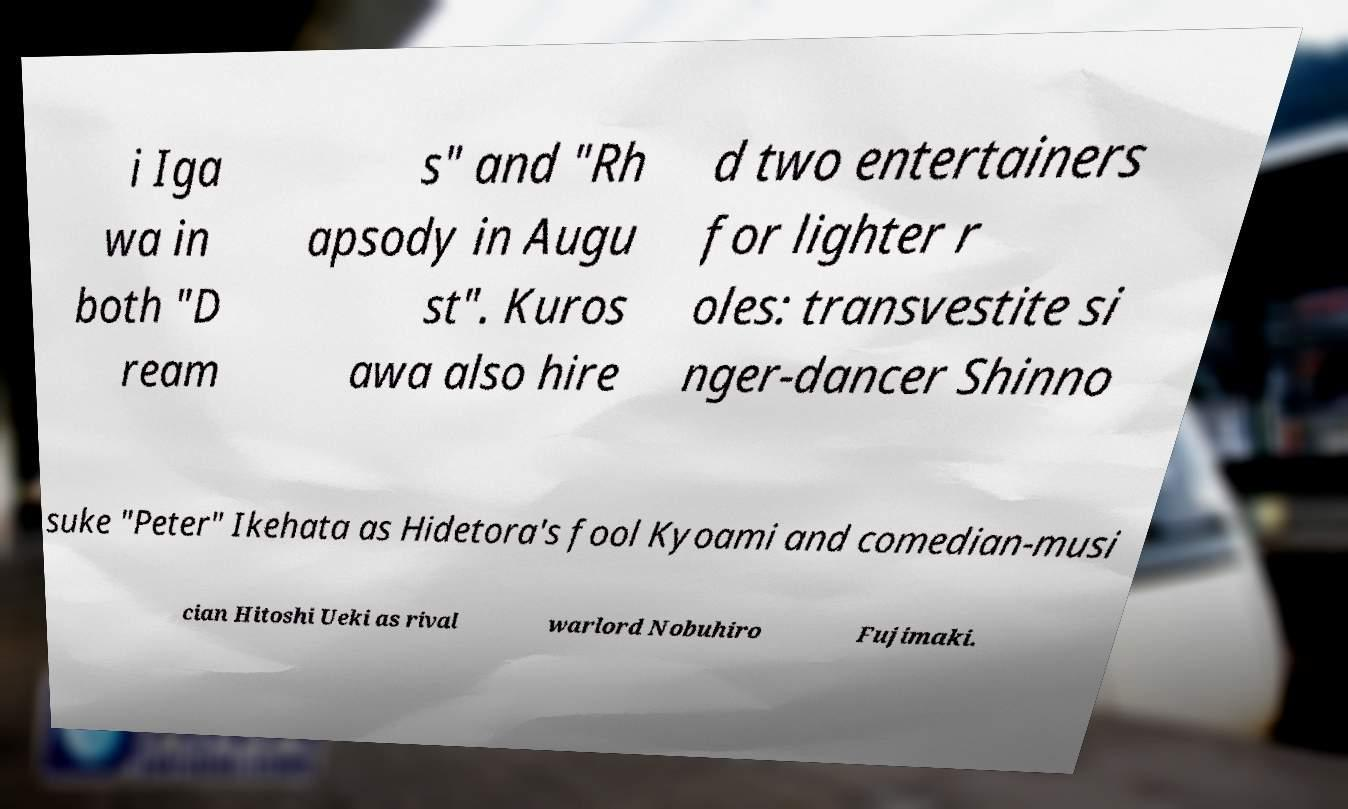Please read and relay the text visible in this image. What does it say? i Iga wa in both "D ream s" and "Rh apsody in Augu st". Kuros awa also hire d two entertainers for lighter r oles: transvestite si nger-dancer Shinno suke "Peter" Ikehata as Hidetora's fool Kyoami and comedian-musi cian Hitoshi Ueki as rival warlord Nobuhiro Fujimaki. 